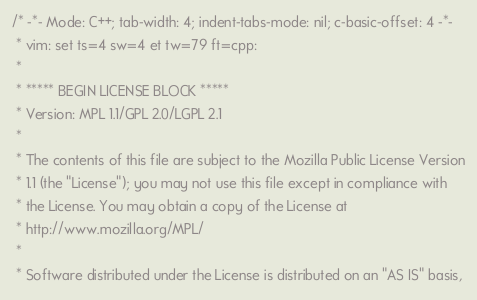Convert code to text. <code><loc_0><loc_0><loc_500><loc_500><_C_>/* -*- Mode: C++; tab-width: 4; indent-tabs-mode: nil; c-basic-offset: 4 -*-
 * vim: set ts=4 sw=4 et tw=79 ft=cpp:
 *
 * ***** BEGIN LICENSE BLOCK *****
 * Version: MPL 1.1/GPL 2.0/LGPL 2.1
 *
 * The contents of this file are subject to the Mozilla Public License Version
 * 1.1 (the "License"); you may not use this file except in compliance with
 * the License. You may obtain a copy of the License at
 * http://www.mozilla.org/MPL/
 *
 * Software distributed under the License is distributed on an "AS IS" basis,</code> 